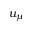Convert formula to latex. <formula><loc_0><loc_0><loc_500><loc_500>u _ { \mu }</formula> 